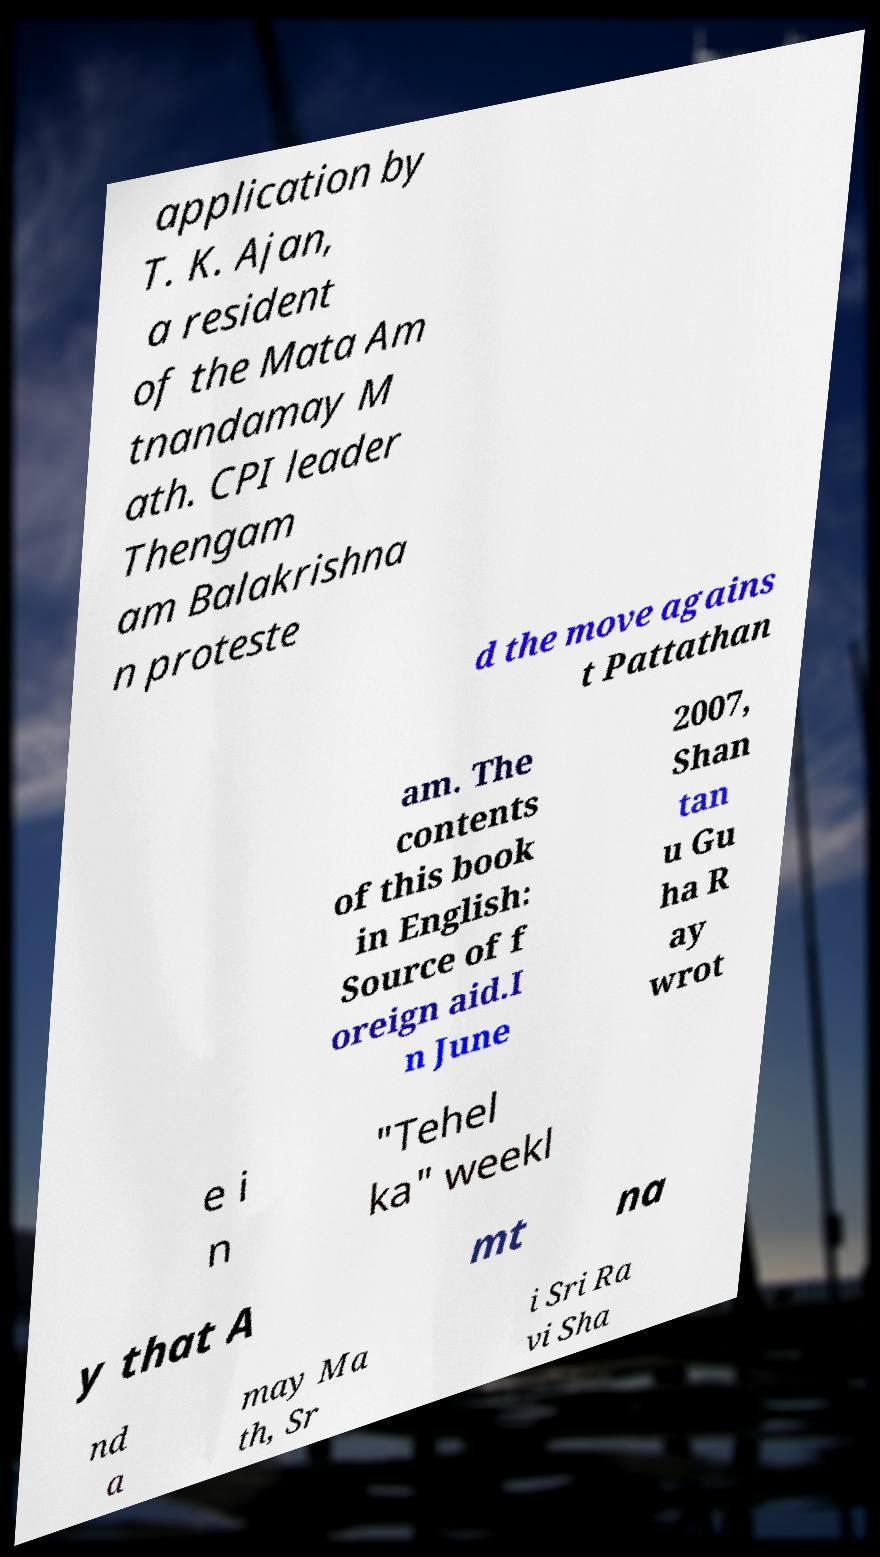Could you extract and type out the text from this image? application by T. K. Ajan, a resident of the Mata Am tnandamay M ath. CPI leader Thengam am Balakrishna n proteste d the move agains t Pattathan am. The contents of this book in English: Source of f oreign aid.I n June 2007, Shan tan u Gu ha R ay wrot e i n "Tehel ka" weekl y that A mt na nd a may Ma th, Sr i Sri Ra vi Sha 